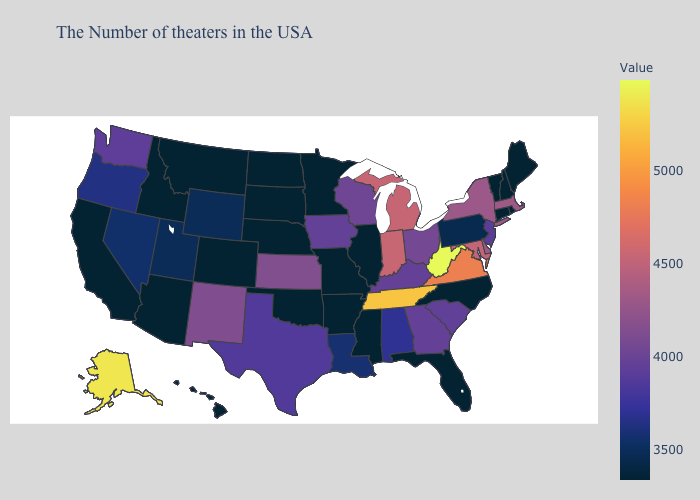Which states have the lowest value in the USA?
Keep it brief. Maine, Rhode Island, New Hampshire, Vermont, Connecticut, North Carolina, Florida, Illinois, Mississippi, Missouri, Arkansas, Minnesota, Nebraska, Oklahoma, South Dakota, North Dakota, Colorado, Montana, Arizona, Idaho, California, Hawaii. Among the states that border Idaho , which have the lowest value?
Quick response, please. Montana. Does North Dakota have the lowest value in the MidWest?
Be succinct. Yes. Among the states that border Idaho , which have the highest value?
Write a very short answer. Washington. Among the states that border South Dakota , does Wyoming have the highest value?
Concise answer only. No. 